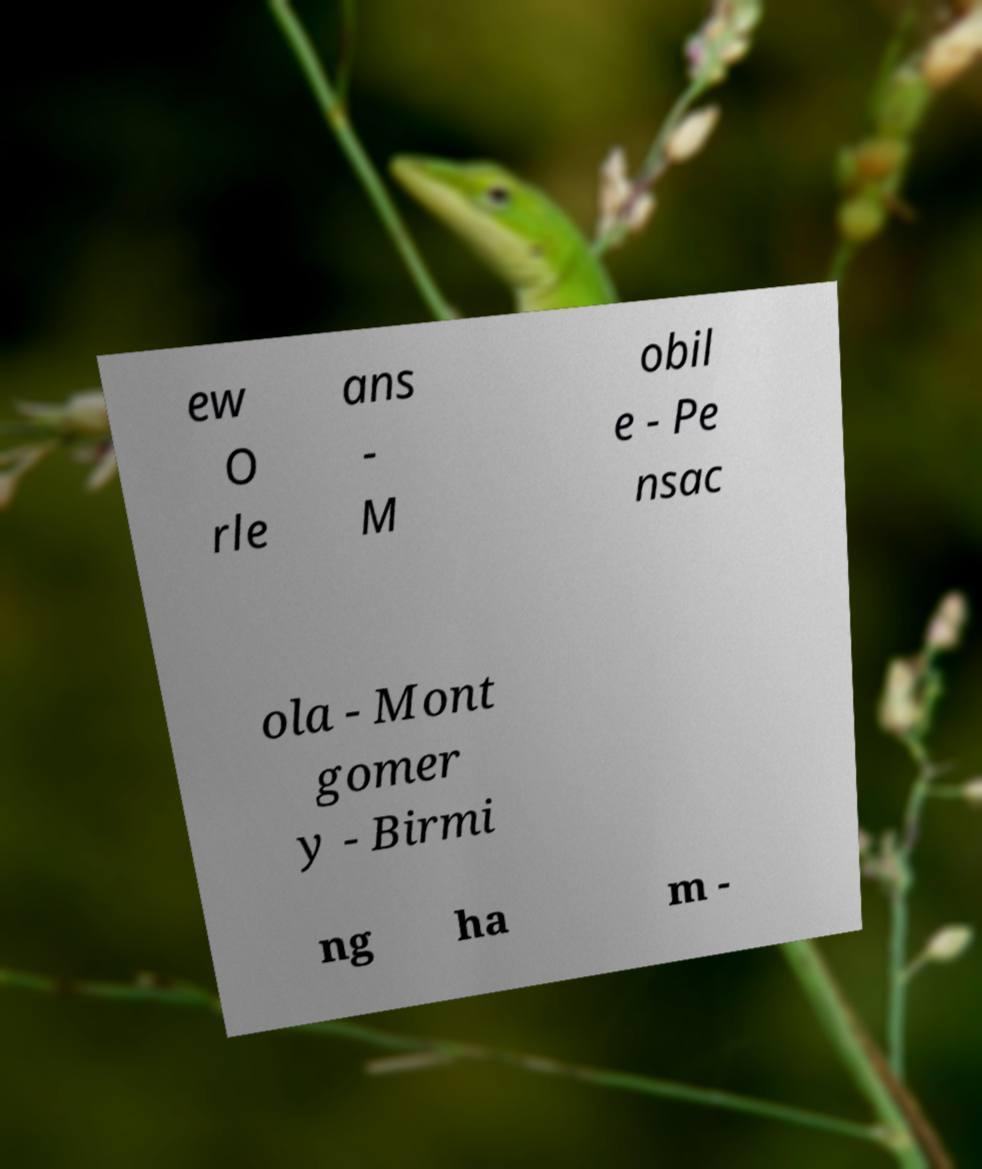I need the written content from this picture converted into text. Can you do that? ew O rle ans - M obil e - Pe nsac ola - Mont gomer y - Birmi ng ha m - 